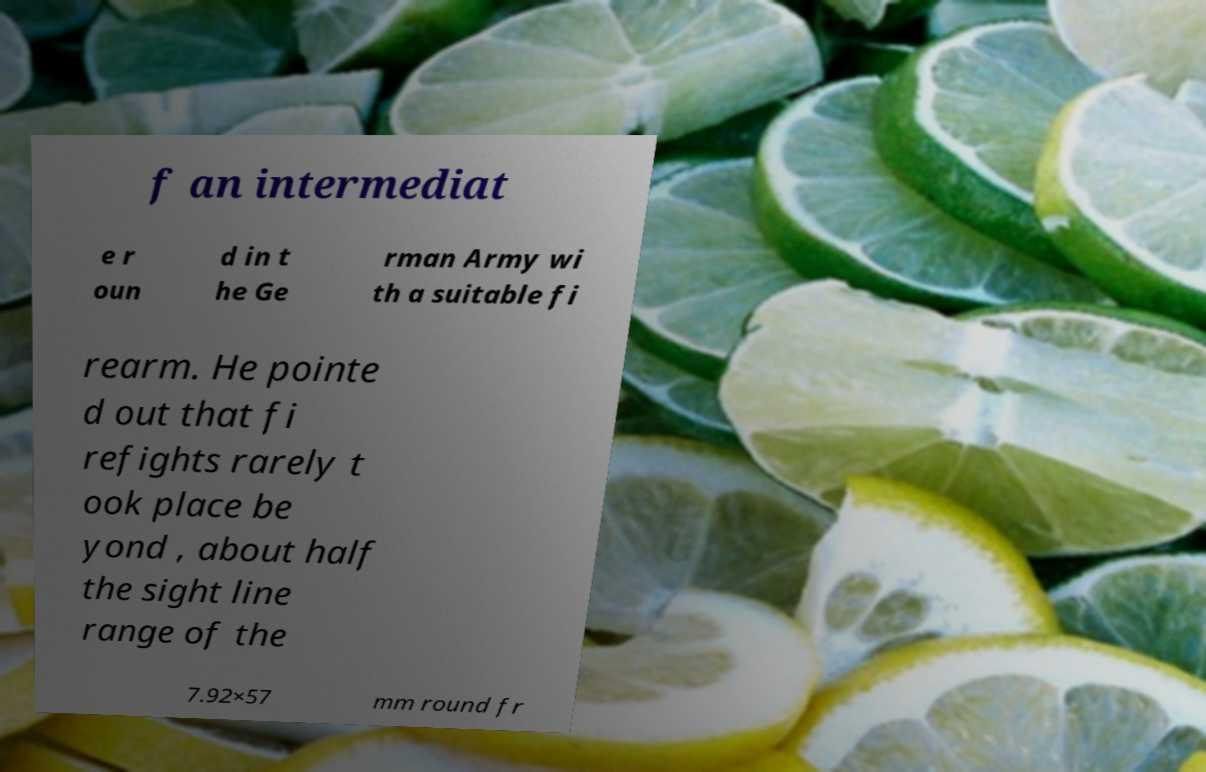Please identify and transcribe the text found in this image. f an intermediat e r oun d in t he Ge rman Army wi th a suitable fi rearm. He pointe d out that fi refights rarely t ook place be yond , about half the sight line range of the 7.92×57 mm round fr 